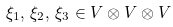Convert formula to latex. <formula><loc_0><loc_0><loc_500><loc_500>\xi _ { 1 } , \, \xi _ { 2 } , \, \xi _ { 3 } \in V \otimes V \otimes V</formula> 